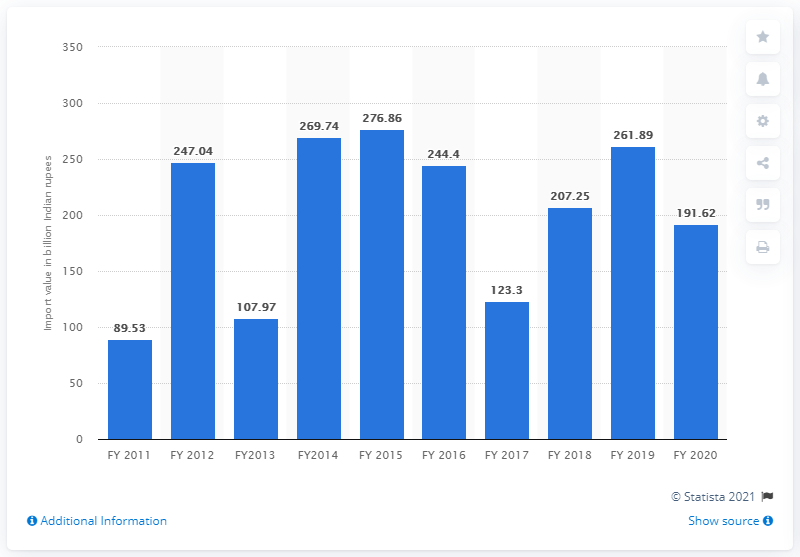Draw attention to some important aspects in this diagram. In the fiscal year 2020, a total of 191.62.. kilograms of silver was imported into India. 